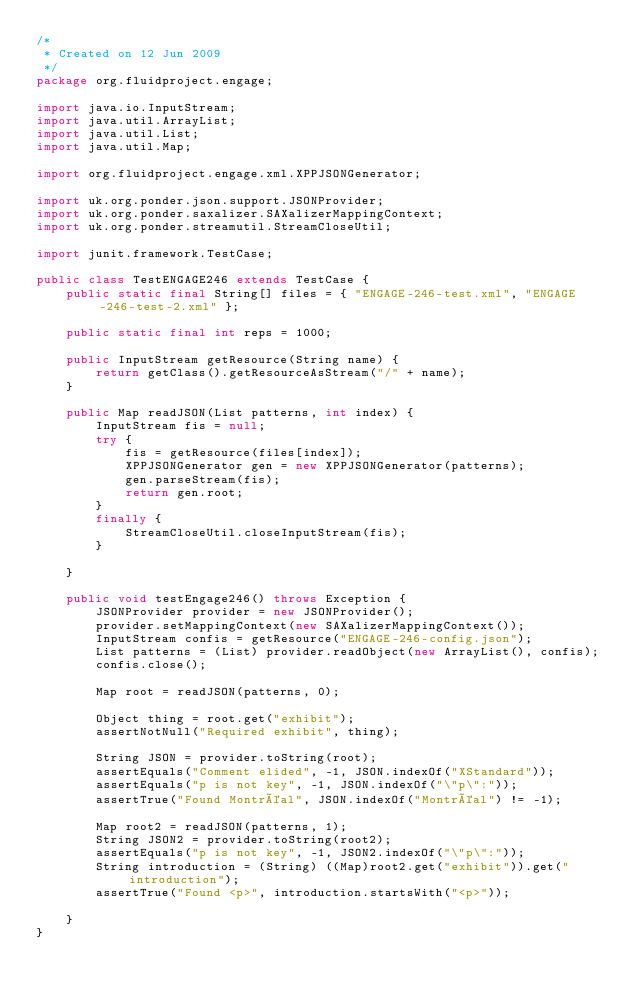Convert code to text. <code><loc_0><loc_0><loc_500><loc_500><_Java_>/*
 * Created on 12 Jun 2009
 */
package org.fluidproject.engage;

import java.io.InputStream;
import java.util.ArrayList;
import java.util.List;
import java.util.Map;

import org.fluidproject.engage.xml.XPPJSONGenerator;

import uk.org.ponder.json.support.JSONProvider;
import uk.org.ponder.saxalizer.SAXalizerMappingContext;
import uk.org.ponder.streamutil.StreamCloseUtil;

import junit.framework.TestCase;

public class TestENGAGE246 extends TestCase {
    public static final String[] files = { "ENGAGE-246-test.xml", "ENGAGE-246-test-2.xml" };

    public static final int reps = 1000;

    public InputStream getResource(String name) {
        return getClass().getResourceAsStream("/" + name);
    }
    
    public Map readJSON(List patterns, int index) {
        InputStream fis = null;
        try {
            fis = getResource(files[index]);
            XPPJSONGenerator gen = new XPPJSONGenerator(patterns);
            gen.parseStream(fis);
            return gen.root;
        }
        finally {
            StreamCloseUtil.closeInputStream(fis);
        }

    }
    
    public void testEngage246() throws Exception {
        JSONProvider provider = new JSONProvider();
        provider.setMappingContext(new SAXalizerMappingContext());
        InputStream confis = getResource("ENGAGE-246-config.json");
        List patterns = (List) provider.readObject(new ArrayList(), confis);
        confis.close();

        Map root = readJSON(patterns, 0);

        Object thing = root.get("exhibit");
        assertNotNull("Required exhibit", thing);

        String JSON = provider.toString(root);
        assertEquals("Comment elided", -1, JSON.indexOf("XStandard"));
        assertEquals("p is not key", -1, JSON.indexOf("\"p\":"));
        assertTrue("Found Montréal", JSON.indexOf("Montréal") != -1);
        
        Map root2 = readJSON(patterns, 1);
        String JSON2 = provider.toString(root2);
        assertEquals("p is not key", -1, JSON2.indexOf("\"p\":"));
        String introduction = (String) ((Map)root2.get("exhibit")).get("introduction");
        assertTrue("Found <p>", introduction.startsWith("<p>"));

    }
}
</code> 